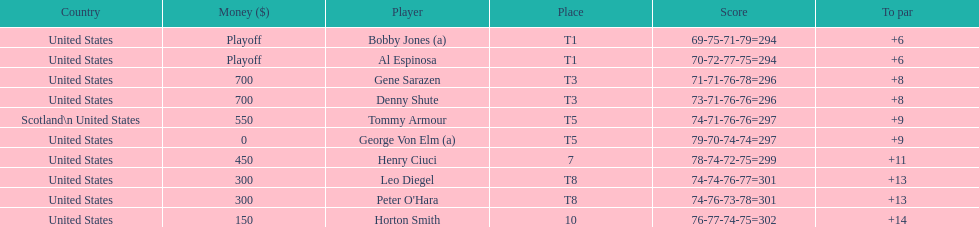How many players represented scotland? 1. 